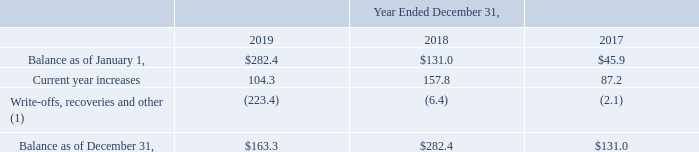AMERICAN TOWER CORPORATION AND SUBSIDIARIES NOTES TO CONSOLIDATED FINANCIAL STATEMENTS (Tabular amounts in millions, unless otherwise disclosed)
Accounts Receivable and Deferred Rent Asset—The Company derives the largest portion of its revenues and corresponding accounts receivable and the related deferred rent asset from a relatively small number of tenants in the telecommunications industry, and 54% of its current-year revenues are derived from four tenants.
The Company’s deferred rent asset is associated with non-cancellable tenant leases that contain fixed escalation clauses over the terms of the applicable lease in which revenue is recognized on a straight-line basis over the lease term.
The Company mitigates its concentrations of credit risk with respect to notes and trade receivables and the related deferred rent assets by actively monitoring the creditworthiness of its borrowers and tenants. In recognizing tenant revenue, the Company assesses the collectibility of both the amounts billed and the portion recognized in advance of billing on a straight-line basis. This assessment takes tenant credit risk and business and industry conditions into consideration to ultimately determine the collectibility of the amounts billed. To the extent the amounts, based on management’s estimates, may not be collectible, revenue recognition is deferred until such point as collectibility is determined to be reasonably assured. Any amounts that were previously recognized as revenue and subsequently determined to be uncollectible are charged to bad debt expense included in Selling, general, administrative and development expense in the accompanying consolidated statements of operations.
Accounts receivable is reported net of allowances for doubtful accounts related to estimated losses resulting from a tenant’s inability to make required payments and allowances for amounts invoiced whose collectibility is not reasonably assured. These allowances are generally estimated based on payment patterns, days past due and collection history, and incorporate changes in economic conditions that may not be reflected in historical trends, such as tenants in bankruptcy, liquidation or reorganization. Receivables are written-off against the allowances when they are determined to be uncollectible. Such determination includes analysis and consideration of the particular conditions of the account. Changes in the allowances were as follows:
(1) In 2019, write-offs are primarily related to uncollectible amounts in India. In 2018 and 2017, recoveries include recognition of revenue resulting from collections of previously reserved amounts.
Where does the company derive the largest portion of its revenues and corresponding accounts receivable and the related deferred rent asset from? A relatively small number of tenants in the telecommunications industry, and 54% of its current-year revenues are derived from four tenants. In 2019, what were the write-offs primarily related to? Uncollectible amounts in india. What was the balance as at January 1, 2019?
Answer scale should be: million. $282.4. What was the change in balance as of January 1 between 2018 and 2019?
Answer scale should be: million. $282.4-$131.0
Answer: 151.4. What was the change in current year increases between 2017 and 2018?
Answer scale should be: million. 157.8-87.2
Answer: 70.6. What was the percentage change in balance as of December 31 between 2018 and 2019?
Answer scale should be: percent. ($163.3-$282.4)/$282.4
Answer: -42.17. 